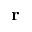Convert formula to latex. <formula><loc_0><loc_0><loc_500><loc_500>r</formula> 